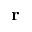Convert formula to latex. <formula><loc_0><loc_0><loc_500><loc_500>r</formula> 